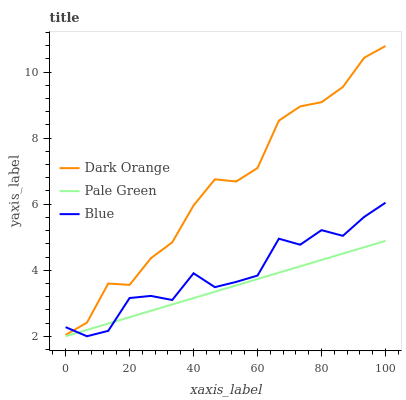Does Pale Green have the minimum area under the curve?
Answer yes or no. Yes. Does Dark Orange have the maximum area under the curve?
Answer yes or no. Yes. Does Dark Orange have the minimum area under the curve?
Answer yes or no. No. Does Pale Green have the maximum area under the curve?
Answer yes or no. No. Is Pale Green the smoothest?
Answer yes or no. Yes. Is Blue the roughest?
Answer yes or no. Yes. Is Dark Orange the smoothest?
Answer yes or no. No. Is Dark Orange the roughest?
Answer yes or no. No. Does Blue have the lowest value?
Answer yes or no. Yes. Does Dark Orange have the lowest value?
Answer yes or no. No. Does Dark Orange have the highest value?
Answer yes or no. Yes. Does Pale Green have the highest value?
Answer yes or no. No. Is Pale Green less than Dark Orange?
Answer yes or no. Yes. Is Dark Orange greater than Pale Green?
Answer yes or no. Yes. Does Pale Green intersect Blue?
Answer yes or no. Yes. Is Pale Green less than Blue?
Answer yes or no. No. Is Pale Green greater than Blue?
Answer yes or no. No. Does Pale Green intersect Dark Orange?
Answer yes or no. No. 